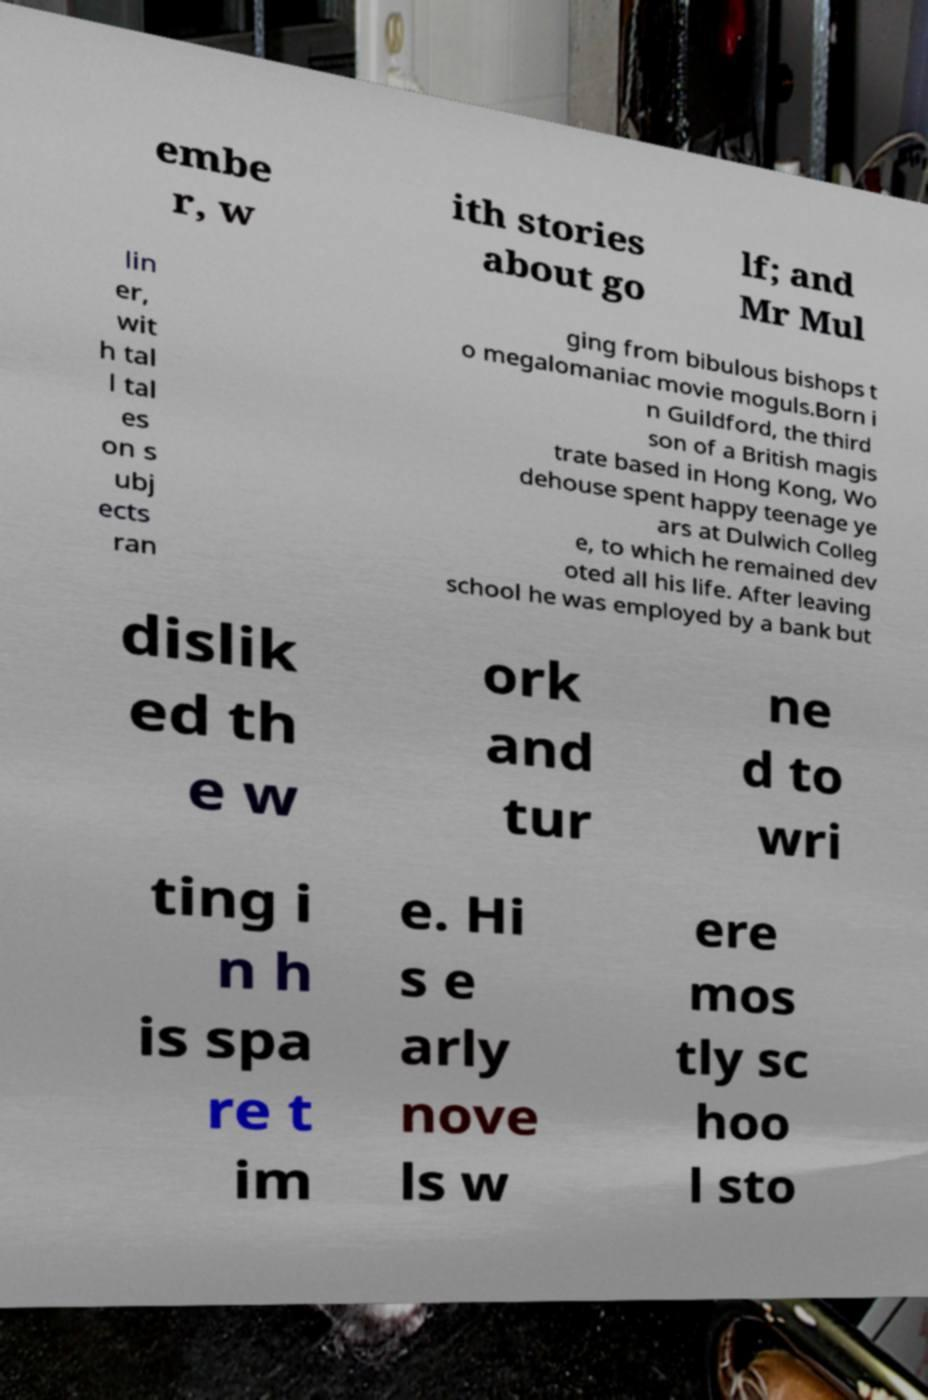For documentation purposes, I need the text within this image transcribed. Could you provide that? embe r, w ith stories about go lf; and Mr Mul lin er, wit h tal l tal es on s ubj ects ran ging from bibulous bishops t o megalomaniac movie moguls.Born i n Guildford, the third son of a British magis trate based in Hong Kong, Wo dehouse spent happy teenage ye ars at Dulwich Colleg e, to which he remained dev oted all his life. After leaving school he was employed by a bank but dislik ed th e w ork and tur ne d to wri ting i n h is spa re t im e. Hi s e arly nove ls w ere mos tly sc hoo l sto 